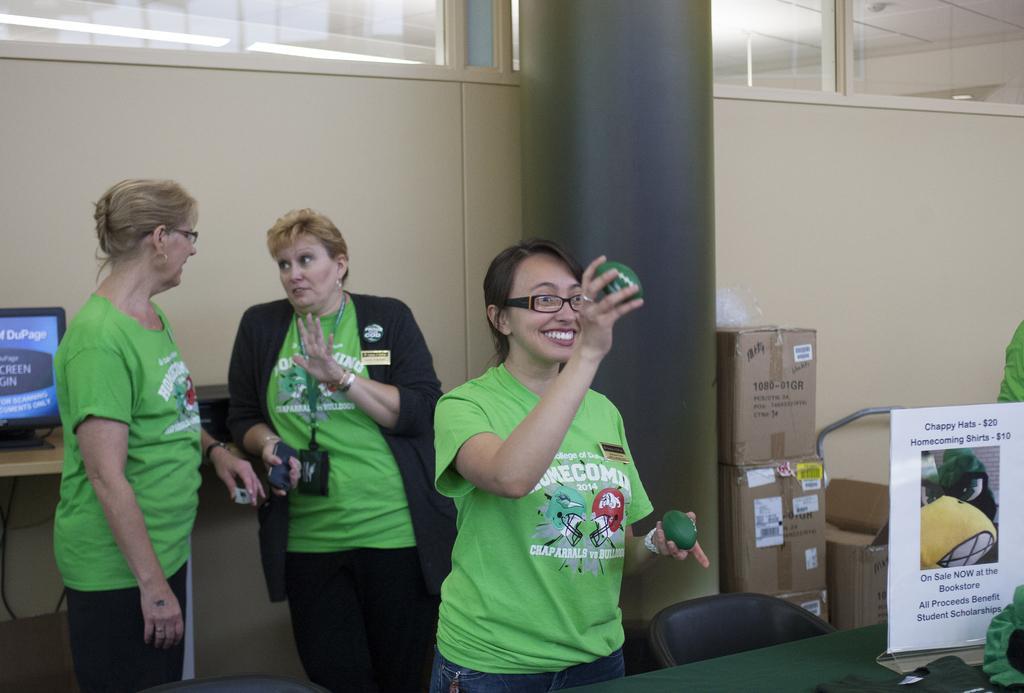Can you describe this image briefly? There is a woman wearing green dress is standing and holding green color objects in her hands and there are two other women standing behind her. 